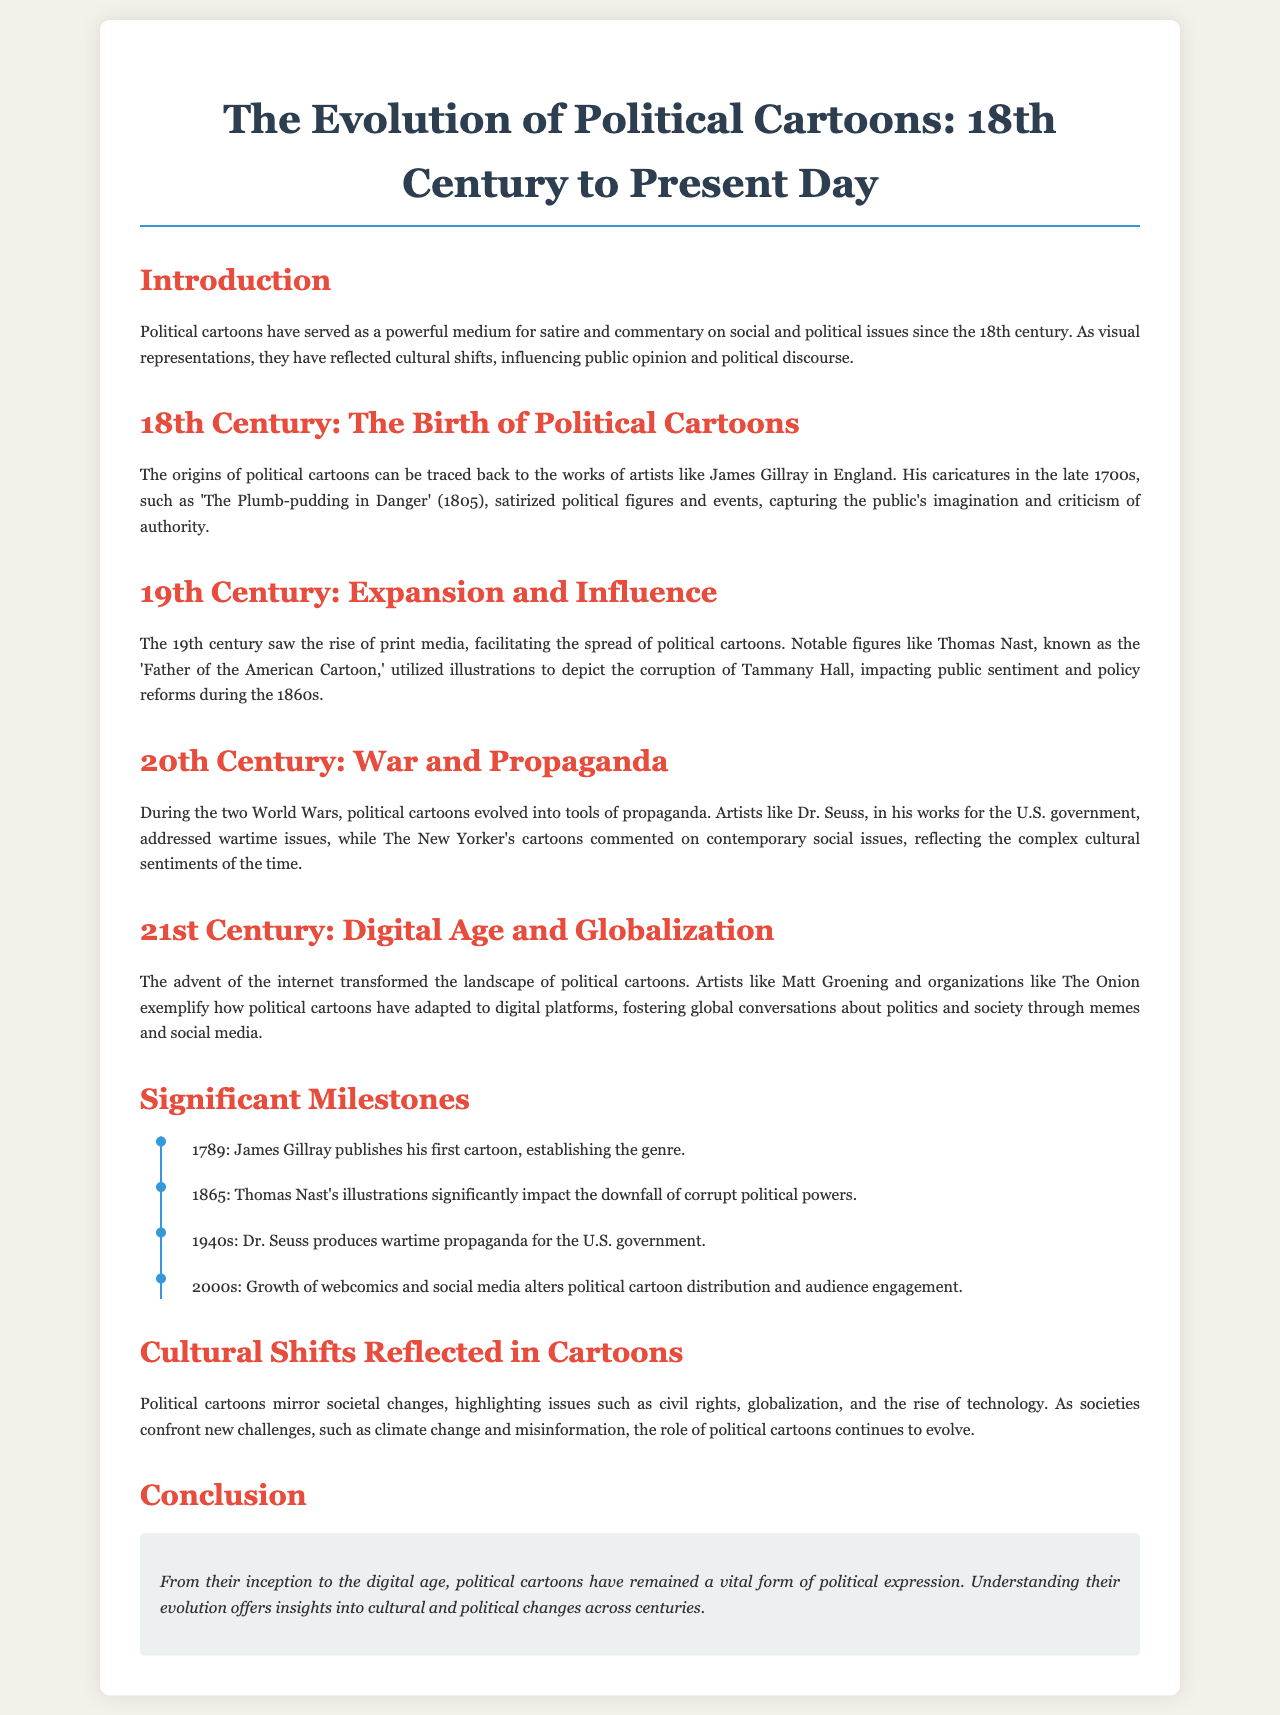What year did James Gillray publish his first cartoon? The document states that James Gillray published his first cartoon in 1789.
Answer: 1789 Who is known as the 'Father of the American Cartoon'? The document identifies Thomas Nast as the 'Father of the American Cartoon'.
Answer: Thomas Nast In which decade did Dr. Seuss produce wartime propaganda? According to the document, Dr. Seuss produced wartime propaganda during the 1940s.
Answer: 1940s What significant change occurred in the 2000s regarding political cartoons? The document mentions that the growth of webcomics and social media altered political cartoon distribution and audience engagement.
Answer: Growth of webcomics and social media How did political cartoons reflect societal changes? The document explains that political cartoons mirror societal changes by highlighting issues such as civil rights, globalization, and the rise of technology.
Answer: By highlighting issues such as civil rights, globalization, and the rise of technology What event marked the downfall of corrupt political powers? The document notes that Thomas Nast's illustrations significantly impacted the downfall of corrupt political powers in 1865.
Answer: 1865 What do political cartoons continue to address in contemporary society? The document states that contemporary political cartoons address new challenges such as climate change and misinformation.
Answer: Climate change and misinformation What is the overall purpose of political cartoons as mentioned in the conclusion? The conclusion states that political cartoons have remained a vital form of political expression.
Answer: A vital form of political expression 